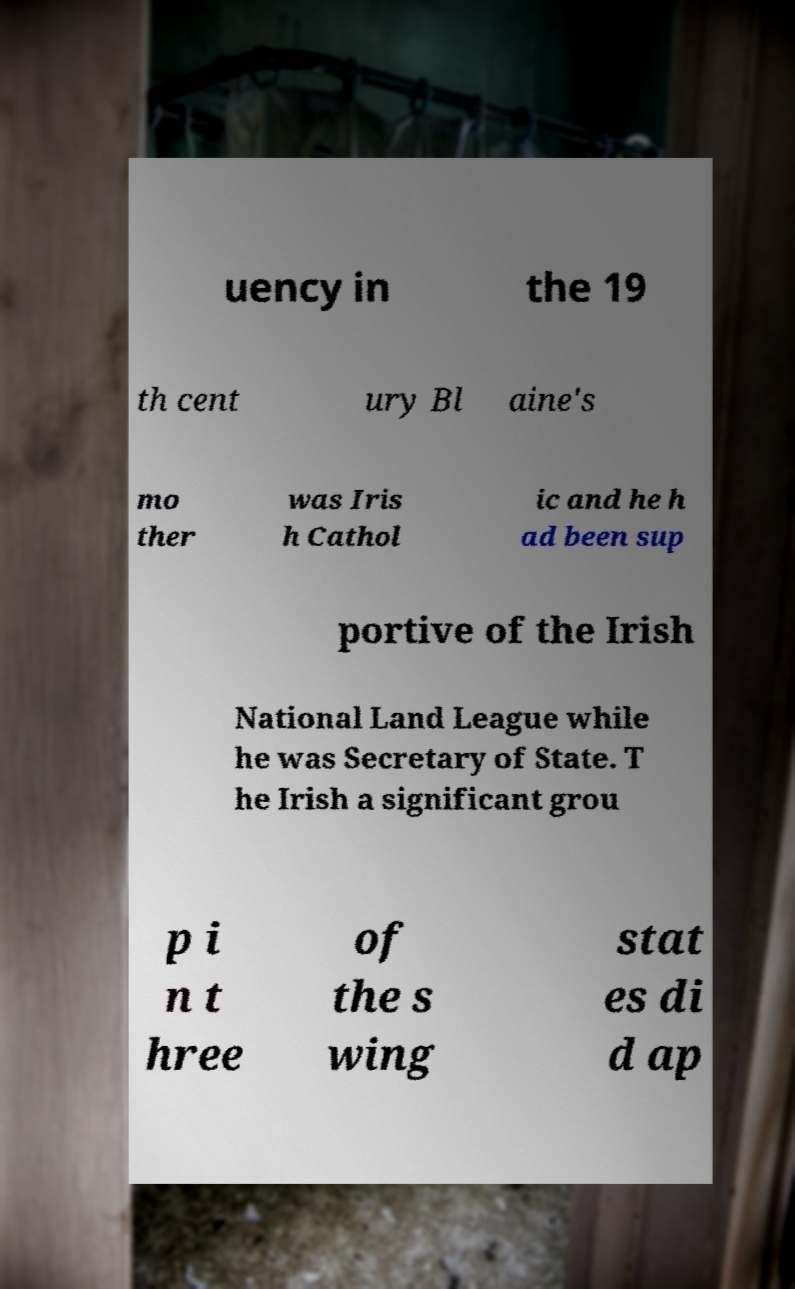There's text embedded in this image that I need extracted. Can you transcribe it verbatim? uency in the 19 th cent ury Bl aine's mo ther was Iris h Cathol ic and he h ad been sup portive of the Irish National Land League while he was Secretary of State. T he Irish a significant grou p i n t hree of the s wing stat es di d ap 